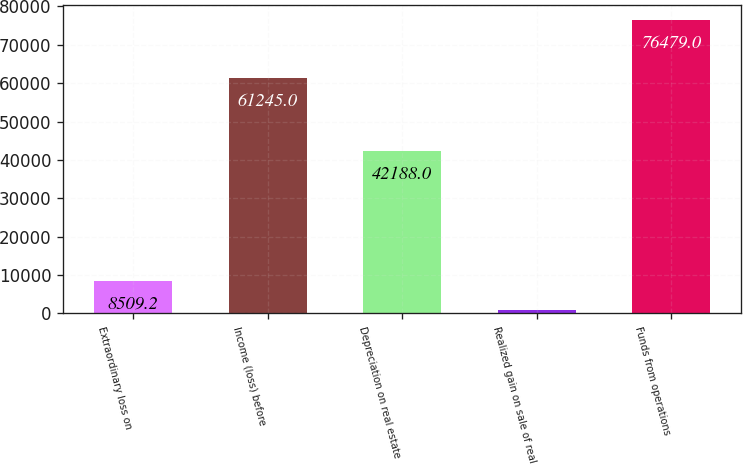Convert chart to OTSL. <chart><loc_0><loc_0><loc_500><loc_500><bar_chart><fcel>Extraordinary loss on<fcel>Income (loss) before<fcel>Depreciation on real estate<fcel>Realized gain on sale of real<fcel>Funds from operations<nl><fcel>8509.2<fcel>61245<fcel>42188<fcel>957<fcel>76479<nl></chart> 